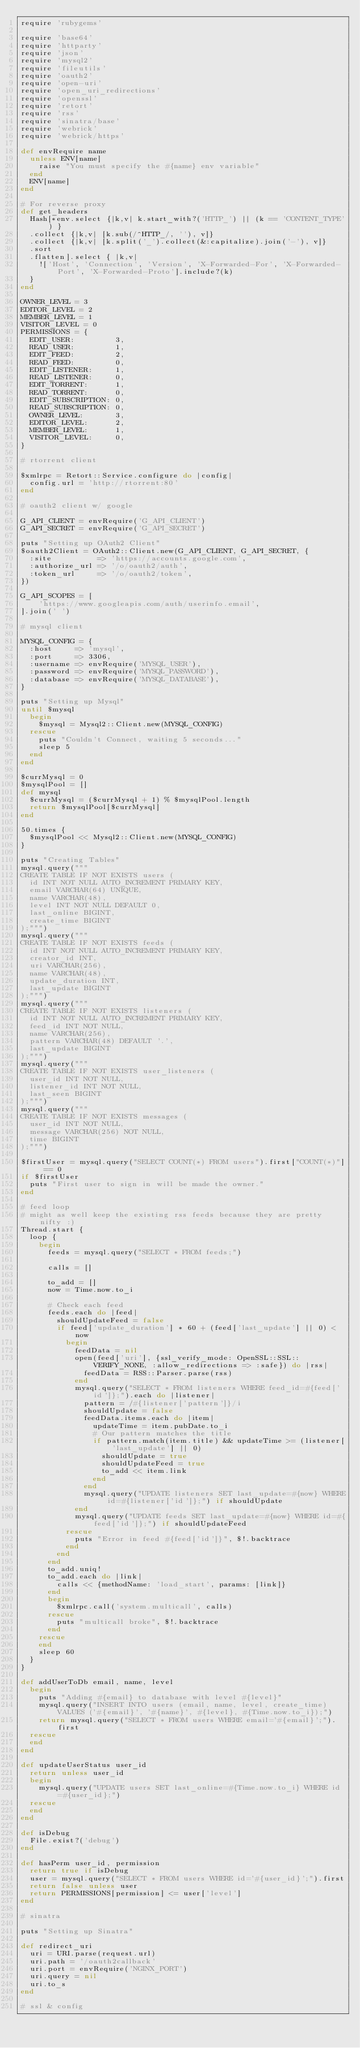Convert code to text. <code><loc_0><loc_0><loc_500><loc_500><_Ruby_>require 'rubygems'

require 'base64'
require 'httparty'
require 'json'
require 'mysql2'
require 'fileutils'
require 'oauth2'
require 'open-uri'
require 'open_uri_redirections'
require 'openssl'
require 'retort'
require 'rss'
require 'sinatra/base'
require 'webrick'
require 'webrick/https'

def envRequire name
  unless ENV[name]
    raise "You must specify the #{name} env variable"
  end
  ENV[name]
end

# For reverse proxy
def get_headers
  Hash[*env.select {|k,v| k.start_with?('HTTP_') || (k == 'CONTENT_TYPE') }
  .collect {|k,v| [k.sub(/^HTTP_/, ''), v]}
  .collect {|k,v| [k.split('_').collect(&:capitalize).join('-'), v]}
  .sort
  .flatten].select { |k,v|
    !['Host', 'Connection', 'Version', 'X-Forwarded-For', 'X-Forwarded-Port', 'X-Forwarded-Proto'].include?(k)
  }
end

OWNER_LEVEL = 3
EDITOR_LEVEL = 2
MEMBER_LEVEL = 1
VISITOR_LEVEL = 0
PERMISSIONS = {
  EDIT_USER:         3,
  READ_USER:         1,
  EDIT_FEED:         2,
  READ_FEED:         0,
  EDIT_LISTENER:     1,
  READ_LISTENER:     0,
  EDIT_TORRENT:      1,
  READ_TORRENT:      0,
  EDIT_SUBSCRIPTION: 0,
  READ_SUBSCRIPTION: 0,
  OWNER_LEVEL:       3,
  EDITOR_LEVEL:      2,
  MEMBER_LEVEL:      1,
  VISITOR_LEVEL:     0,
}

# rtorrent client

$xmlrpc = Retort::Service.configure do |config| 
  config.url = 'http://rtorrent:80'
end

# oauth2 client w/ google

G_API_CLIENT = envRequire('G_API_CLIENT')
G_API_SECRET = envRequire('G_API_SECRET')

puts "Setting up OAuth2 Client"
$oauth2Client = OAuth2::Client.new(G_API_CLIENT, G_API_SECRET, {
  :site          => 'https://accounts.google.com',
  :authorize_url => '/o/oauth2/auth',
  :token_url     => '/o/oauth2/token',
})

G_API_SCOPES = [
    'https://www.googleapis.com/auth/userinfo.email',
].join(' ')

# mysql client

MYSQL_CONFIG = {
  :host     => 'mysql',
  :port     => 3306,
  :username => envRequire('MYSQL_USER'),
  :password => envRequire('MYSQL_PASSWORD'),
  :database => envRequire('MYSQL_DATABASE'),
}

puts "Setting up Mysql"
until $mysql
  begin
    $mysql = Mysql2::Client.new(MYSQL_CONFIG)
  rescue
    puts "Couldn't Connect, waiting 5 seconds..."
    sleep 5
  end
end

$currMysql = 0
$mysqlPool = []
def mysql
  $currMysql = ($currMysql + 1) % $mysqlPool.length
  return $mysqlPool[$currMysql]
end

50.times {
  $mysqlPool << Mysql2::Client.new(MYSQL_CONFIG)
}

puts "Creating Tables"
mysql.query("""
CREATE TABLE IF NOT EXISTS users (
  id INT NOT NULL AUTO_INCREMENT PRIMARY KEY,
  email VARCHAR(64) UNIQUE,
  name VARCHAR(48),
  level INT NOT NULL DEFAULT 0,
  last_online BIGINT,
  create_time BIGINT
);""")
mysql.query("""
CREATE TABLE IF NOT EXISTS feeds (
  id INT NOT NULL AUTO_INCREMENT PRIMARY KEY,
  creator_id INT,
  uri VARCHAR(256),
  name VARCHAR(48),
  update_duration INT,
  last_update BIGINT
);""")
mysql.query("""
CREATE TABLE IF NOT EXISTS listeners (
  id INT NOT NULL AUTO_INCREMENT PRIMARY KEY,
  feed_id INT NOT NULL,
  name VARCHAR(256),
  pattern VARCHAR(48) DEFAULT '.',
  last_update BIGINT
);""")
mysql.query("""
CREATE TABLE IF NOT EXISTS user_listeners (
  user_id INT NOT NULL,
  listener_id INT NOT NULL,
  last_seen BIGINT
);""")
mysql.query("""
CREATE TABLE IF NOT EXISTS messages (
  user_id INT NOT NULL,
  message VARCHAR(256) NOT NULL,
  time BIGINT
);""")

$firstUser = mysql.query("SELECT COUNT(*) FROM users").first["COUNT(*)"] == 0
if $firstUser
  puts "First user to sign in will be made the owner."
end

# feed loop
# might as well keep the existing rss feeds because they are pretty nifty :)
Thread.start {
  loop {
    begin
      feeds = mysql.query("SELECT * FROM feeds;")

      calls = []

      to_add = []
      now = Time.now.to_i

      # Check each feed
      feeds.each do |feed|
        shouldUpdateFeed = false
        if feed['update_duration'] * 60 + (feed['last_update'] || 0) < now
          begin
            feedData = nil
            open(feed['uri'], {ssl_verify_mode: OpenSSL::SSL::VERIFY_NONE, :allow_redirections => :safe}) do |rss|
              feedData = RSS::Parser.parse(rss)
            end
            mysql.query("SELECT * FROM listeners WHERE feed_id=#{feed['id']};").each do |listener|
              pattern = /#{listener['pattern']}/i
              shouldUpdate = false
              feedData.items.each do |item|
                updateTime = item.pubDate.to_i
                # Our pattern matches the title
                if pattern.match(item.title) && updateTime >= (listener['last_update'] || 0)
                  shouldUpdate = true
                  shouldUpdateFeed = true
                  to_add << item.link
                end
              end
              mysql.query("UPDATE listeners SET last_update=#{now} WHERE id=#{listener['id']};") if shouldUpdate
            end
            mysql.query("UPDATE feeds SET last_update=#{now} WHERE id=#{feed['id']};") if shouldUpdateFeed
          rescue
            puts "Error in feed #{feed['id']}", $!.backtrace
          end
        end
      end
      to_add.uniq!
      to_add.each do |link|
        calls << {methodName: 'load_start', params: [link]}
      end
      begin
        $xmlrpc.call('system.multicall', calls)
      rescue
        puts "multicall broke", $!.backtrace
      end
    rescue
    end
    sleep 60
  }
}

def addUserToDb email, name, level
  begin
    puts "Adding #{email} to database with level #{level}"
    mysql.query("INSERT INTO users (email, name, level, create_time) VALUES ('#{email}', '#{name}', #{level}, #{Time.now.to_i});")
    return mysql.query("SELECT * FROM users WHERE email='#{email}';").first
  rescue
  end
end

def updateUserStatus user_id
  return unless user_id
  begin
    mysql.query("UPDATE users SET last_online=#{Time.now.to_i} WHERE id=#{user_id};")
  rescue
  end
end

def isDebug
  File.exist?('debug')
end

def hasPerm user_id, permission
  return true if isDebug
  user = mysql.query("SELECT * FROM users WHERE id='#{user_id}';").first
  return false unless user
  return PERMISSIONS[permission] <= user['level']
end

# sinatra

puts "Setting up Sinatra"

def redirect_uri
  uri = URI.parse(request.url)
  uri.path = '/oauth2callback'
  uri.port = envRequire('NGINX_PORT')
  uri.query = nil
  uri.to_s
end

# ssl & config</code> 